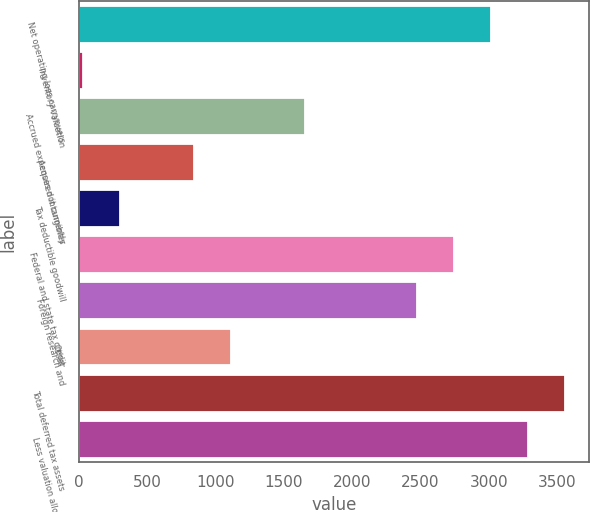Convert chart to OTSL. <chart><loc_0><loc_0><loc_500><loc_500><bar_chart><fcel>Net operating loss carryovers<fcel>Inventory valuation<fcel>Accrued expenses not currently<fcel>Acquired intangibles<fcel>Tax deductible goodwill<fcel>Federal and state tax credit<fcel>Foreign research and<fcel>Other<fcel>Total deferred tax assets<fcel>Less valuation allowance<nl><fcel>3014.8<fcel>25<fcel>1655.8<fcel>840.4<fcel>296.8<fcel>2743<fcel>2471.2<fcel>1112.2<fcel>3558.4<fcel>3286.6<nl></chart> 